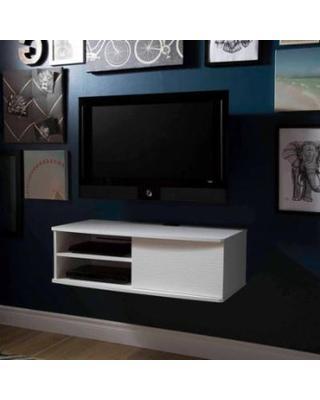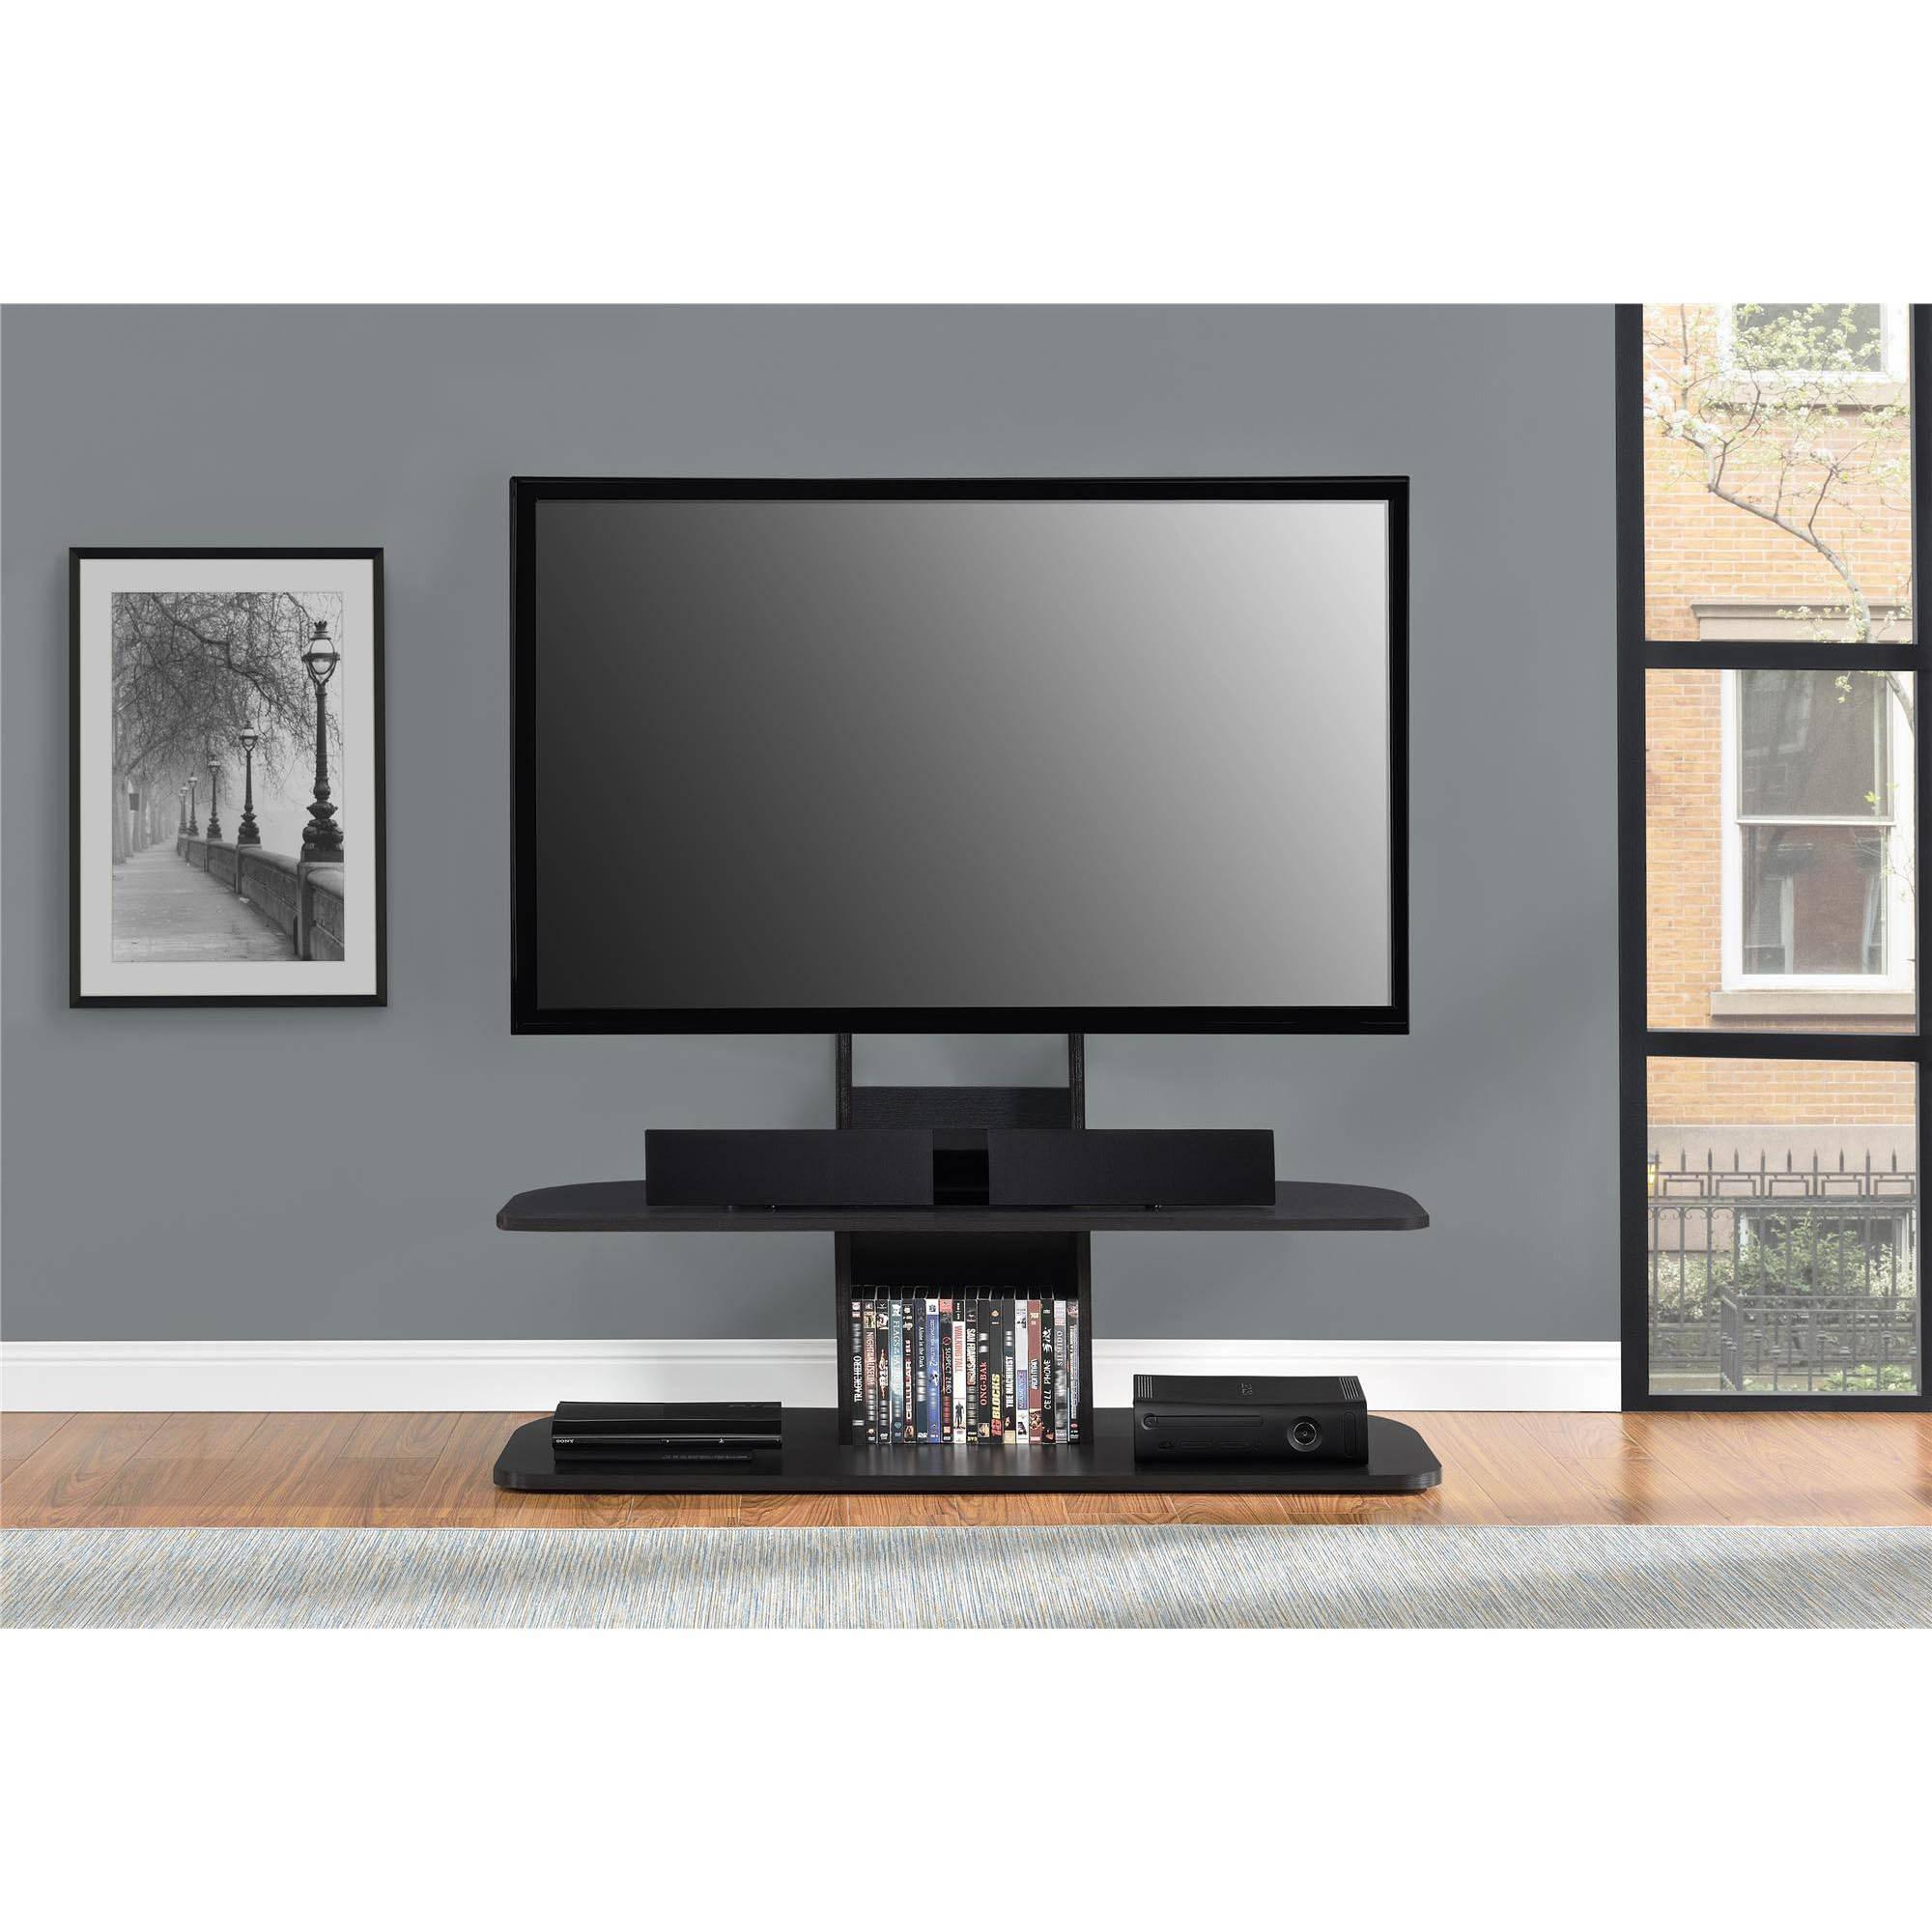The first image is the image on the left, the second image is the image on the right. Analyze the images presented: Is the assertion "multiple tv's are mounted to a single wall" valid? Answer yes or no. No. The first image is the image on the left, the second image is the image on the right. Evaluate the accuracy of this statement regarding the images: "There are multiple screens in the right image.". Is it true? Answer yes or no. No. 